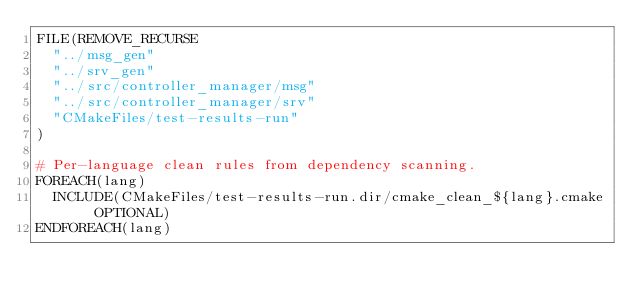<code> <loc_0><loc_0><loc_500><loc_500><_CMake_>FILE(REMOVE_RECURSE
  "../msg_gen"
  "../srv_gen"
  "../src/controller_manager/msg"
  "../src/controller_manager/srv"
  "CMakeFiles/test-results-run"
)

# Per-language clean rules from dependency scanning.
FOREACH(lang)
  INCLUDE(CMakeFiles/test-results-run.dir/cmake_clean_${lang}.cmake OPTIONAL)
ENDFOREACH(lang)
</code> 